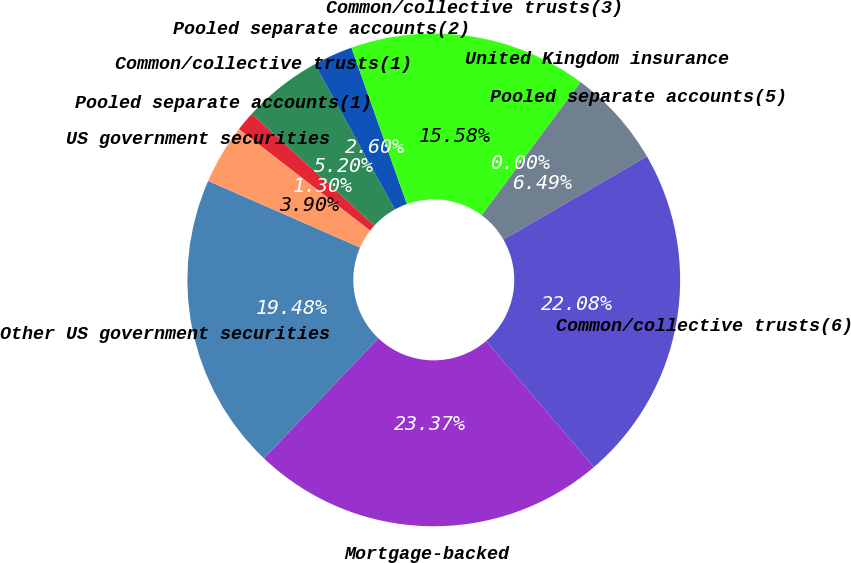Convert chart to OTSL. <chart><loc_0><loc_0><loc_500><loc_500><pie_chart><fcel>Pooled separate accounts(1)<fcel>Common/collective trusts(1)<fcel>Pooled separate accounts(2)<fcel>Common/collective trusts(3)<fcel>United Kingdom insurance<fcel>Pooled separate accounts(5)<fcel>Common/collective trusts(6)<fcel>Mortgage-backed<fcel>Other US government securities<fcel>US government securities<nl><fcel>1.3%<fcel>5.2%<fcel>2.6%<fcel>15.58%<fcel>0.0%<fcel>6.49%<fcel>22.08%<fcel>23.37%<fcel>19.48%<fcel>3.9%<nl></chart> 